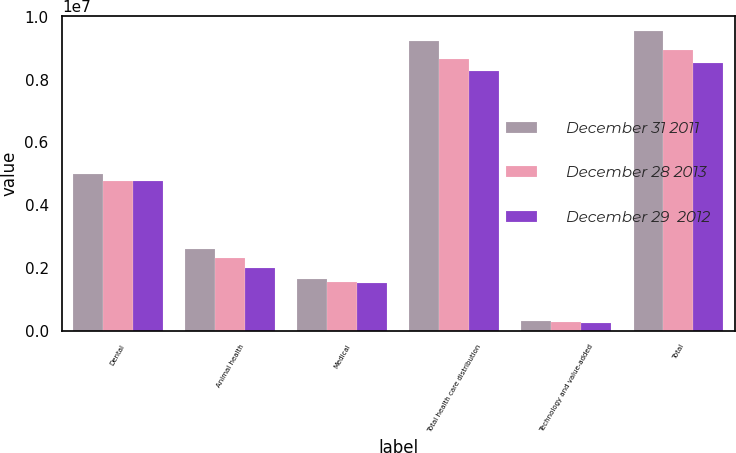<chart> <loc_0><loc_0><loc_500><loc_500><stacked_bar_chart><ecel><fcel>Dental<fcel>Animal health<fcel>Medical<fcel>Total health care distribution<fcel>Technology and value-added<fcel>Total<nl><fcel>December 31 2011<fcel>4.99797e+06<fcel>2.59946e+06<fcel>1.64317e+06<fcel>9.2406e+06<fcel>320047<fcel>9.56065e+06<nl><fcel>December 28 2013<fcel>4.77448e+06<fcel>2.32115e+06<fcel>1.56092e+06<fcel>8.65655e+06<fcel>283413<fcel>8.93997e+06<nl><fcel>December 29  2012<fcel>4.7649e+06<fcel>2.01027e+06<fcel>1.50445e+06<fcel>8.27962e+06<fcel>250620<fcel>8.53024e+06<nl></chart> 